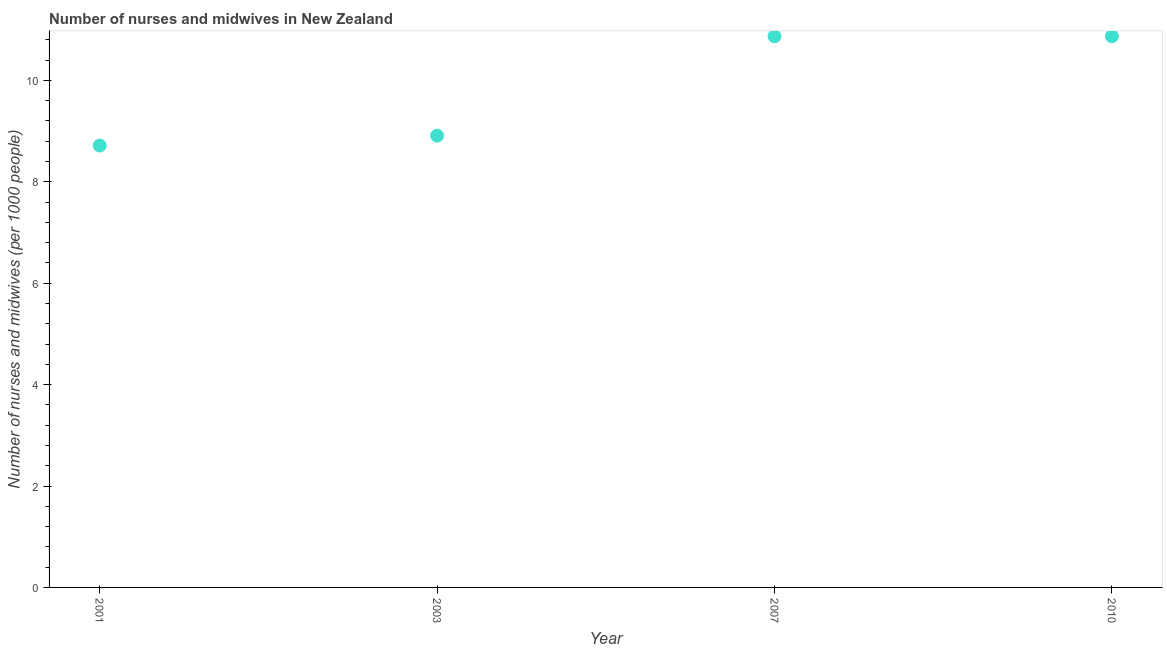What is the number of nurses and midwives in 2010?
Provide a succinct answer. 10.87. Across all years, what is the maximum number of nurses and midwives?
Give a very brief answer. 10.87. Across all years, what is the minimum number of nurses and midwives?
Your response must be concise. 8.71. What is the sum of the number of nurses and midwives?
Give a very brief answer. 39.36. What is the difference between the number of nurses and midwives in 2007 and 2010?
Keep it short and to the point. 0. What is the average number of nurses and midwives per year?
Your answer should be very brief. 9.84. What is the median number of nurses and midwives?
Make the answer very short. 9.89. Do a majority of the years between 2007 and 2010 (inclusive) have number of nurses and midwives greater than 6 ?
Ensure brevity in your answer.  Yes. What is the ratio of the number of nurses and midwives in 2001 to that in 2010?
Your answer should be very brief. 0.8. Is the difference between the number of nurses and midwives in 2001 and 2010 greater than the difference between any two years?
Ensure brevity in your answer.  Yes. What is the difference between the highest and the second highest number of nurses and midwives?
Ensure brevity in your answer.  0. Is the sum of the number of nurses and midwives in 2007 and 2010 greater than the maximum number of nurses and midwives across all years?
Ensure brevity in your answer.  Yes. What is the difference between the highest and the lowest number of nurses and midwives?
Your answer should be very brief. 2.15. In how many years, is the number of nurses and midwives greater than the average number of nurses and midwives taken over all years?
Offer a terse response. 2. Does the number of nurses and midwives monotonically increase over the years?
Give a very brief answer. No. How many dotlines are there?
Your response must be concise. 1. Does the graph contain grids?
Offer a terse response. No. What is the title of the graph?
Your response must be concise. Number of nurses and midwives in New Zealand. What is the label or title of the Y-axis?
Offer a terse response. Number of nurses and midwives (per 1000 people). What is the Number of nurses and midwives (per 1000 people) in 2001?
Give a very brief answer. 8.71. What is the Number of nurses and midwives (per 1000 people) in 2003?
Keep it short and to the point. 8.91. What is the Number of nurses and midwives (per 1000 people) in 2007?
Offer a terse response. 10.87. What is the Number of nurses and midwives (per 1000 people) in 2010?
Your answer should be very brief. 10.87. What is the difference between the Number of nurses and midwives (per 1000 people) in 2001 and 2003?
Provide a short and direct response. -0.2. What is the difference between the Number of nurses and midwives (per 1000 people) in 2001 and 2007?
Give a very brief answer. -2.15. What is the difference between the Number of nurses and midwives (per 1000 people) in 2001 and 2010?
Ensure brevity in your answer.  -2.15. What is the difference between the Number of nurses and midwives (per 1000 people) in 2003 and 2007?
Offer a terse response. -1.96. What is the difference between the Number of nurses and midwives (per 1000 people) in 2003 and 2010?
Provide a short and direct response. -1.96. What is the difference between the Number of nurses and midwives (per 1000 people) in 2007 and 2010?
Offer a very short reply. 0. What is the ratio of the Number of nurses and midwives (per 1000 people) in 2001 to that in 2003?
Your response must be concise. 0.98. What is the ratio of the Number of nurses and midwives (per 1000 people) in 2001 to that in 2007?
Give a very brief answer. 0.8. What is the ratio of the Number of nurses and midwives (per 1000 people) in 2001 to that in 2010?
Provide a succinct answer. 0.8. What is the ratio of the Number of nurses and midwives (per 1000 people) in 2003 to that in 2007?
Keep it short and to the point. 0.82. What is the ratio of the Number of nurses and midwives (per 1000 people) in 2003 to that in 2010?
Offer a very short reply. 0.82. What is the ratio of the Number of nurses and midwives (per 1000 people) in 2007 to that in 2010?
Your answer should be compact. 1. 